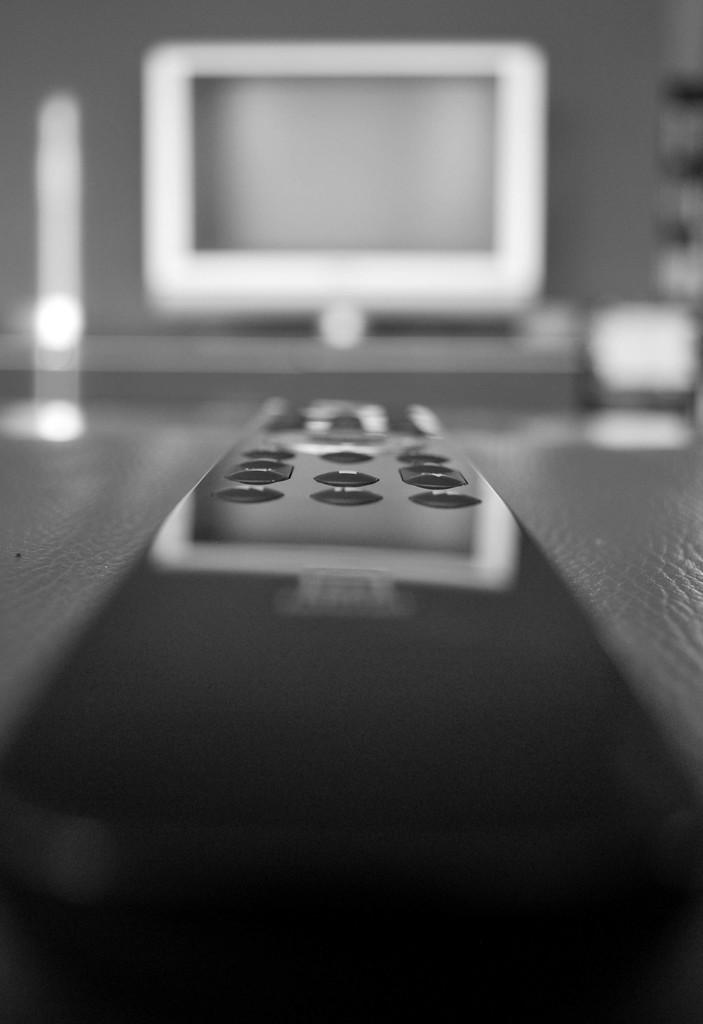What object is placed on a platform in the image? There is a remote on a platform in the image. What can be seen in the background of the image? There is a monitor and a wall in the background of the image. What type of basket is used to mark the territory in the image? There is no basket or territory present in the image. What type of magic is being performed with the remote in the image? There is no magic or indication of any supernatural activity in the image; it simply shows a remote on a platform. 